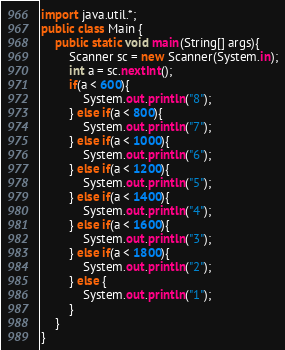<code> <loc_0><loc_0><loc_500><loc_500><_Java_>import java.util.*;
public class Main {
	public static void main(String[] args){
		Scanner sc = new Scanner(System.in);
		int a = sc.nextInt();
		if(a < 600){
			System.out.println("8");
        } else if(a < 800){
          	System.out.println("7");
        } else if(a < 1000){
          	System.out.println("6");
        } else if(a < 1200){
         	System.out.println("5");
        } else if(a < 1400){
          	System.out.println("4");
        } else if(a < 1600){
          	System.out.println("3");
        } else if(a < 1800){
          	System.out.println("2");
        } else {
        	System.out.println("1");
        }
	}
}</code> 